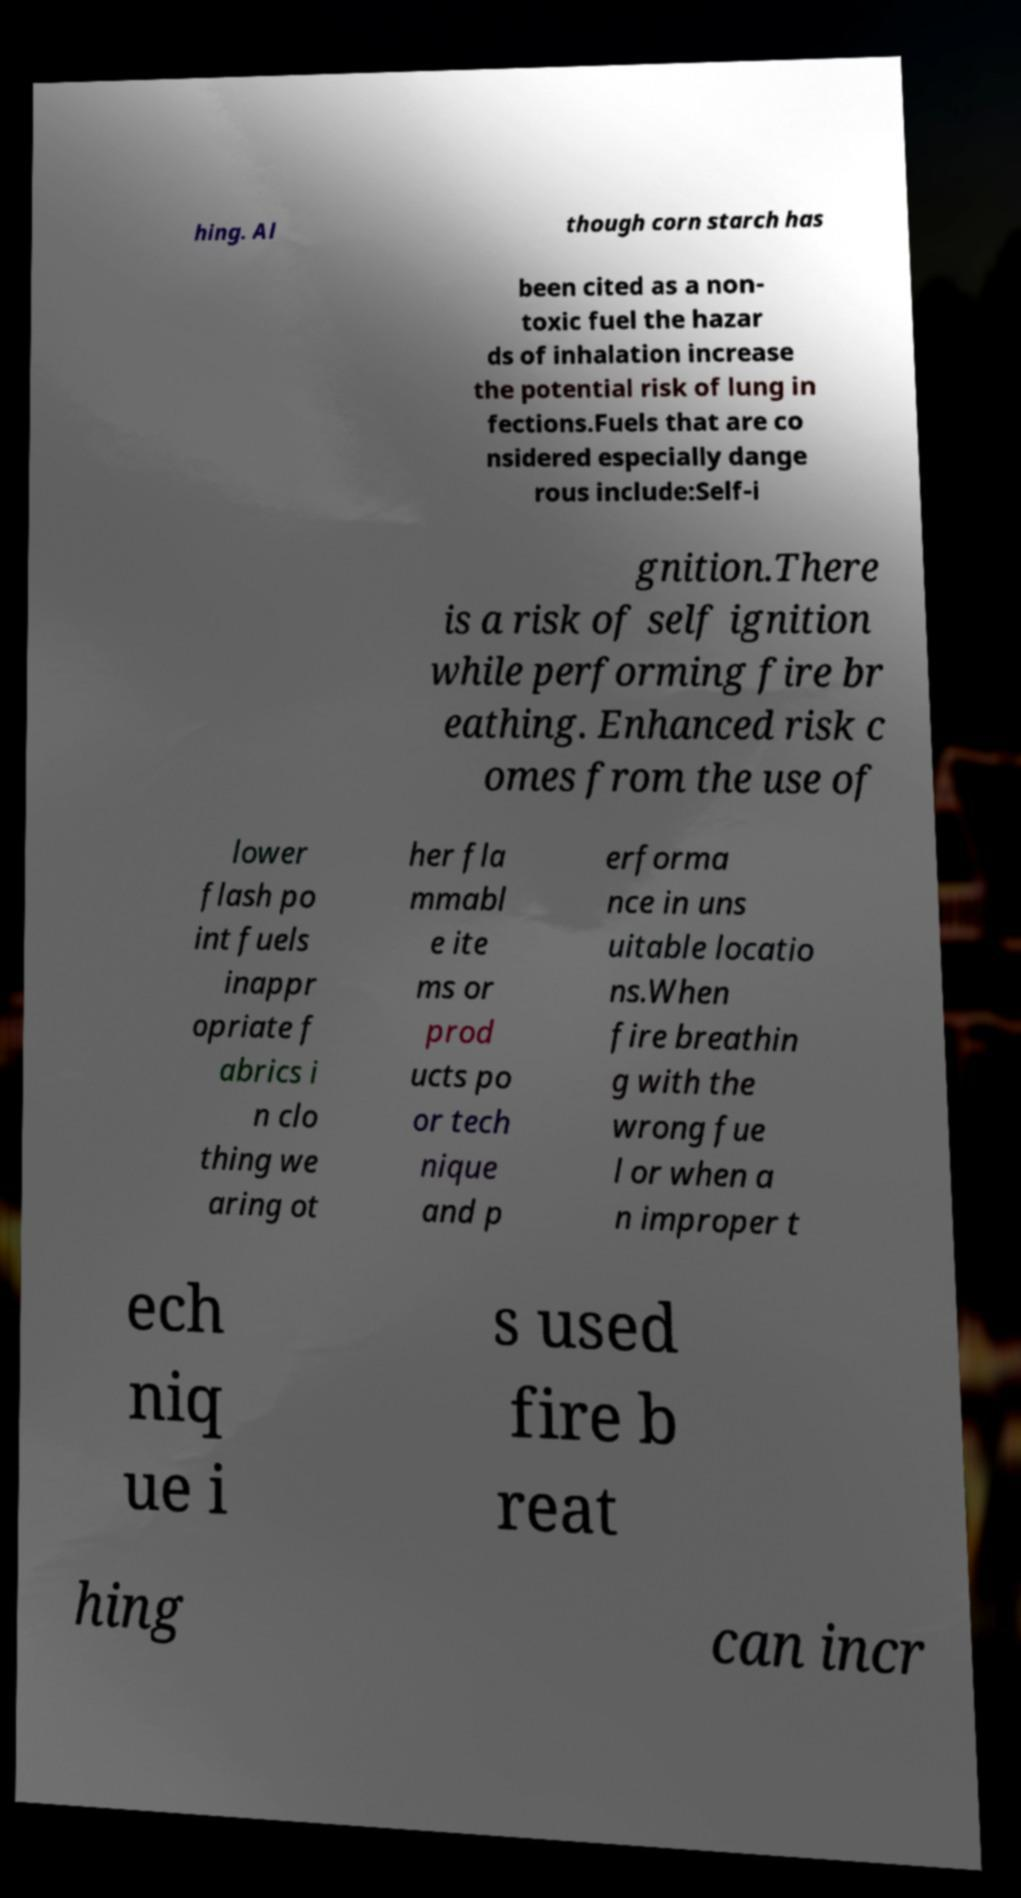There's text embedded in this image that I need extracted. Can you transcribe it verbatim? hing. Al though corn starch has been cited as a non- toxic fuel the hazar ds of inhalation increase the potential risk of lung in fections.Fuels that are co nsidered especially dange rous include:Self-i gnition.There is a risk of self ignition while performing fire br eathing. Enhanced risk c omes from the use of lower flash po int fuels inappr opriate f abrics i n clo thing we aring ot her fla mmabl e ite ms or prod ucts po or tech nique and p erforma nce in uns uitable locatio ns.When fire breathin g with the wrong fue l or when a n improper t ech niq ue i s used fire b reat hing can incr 